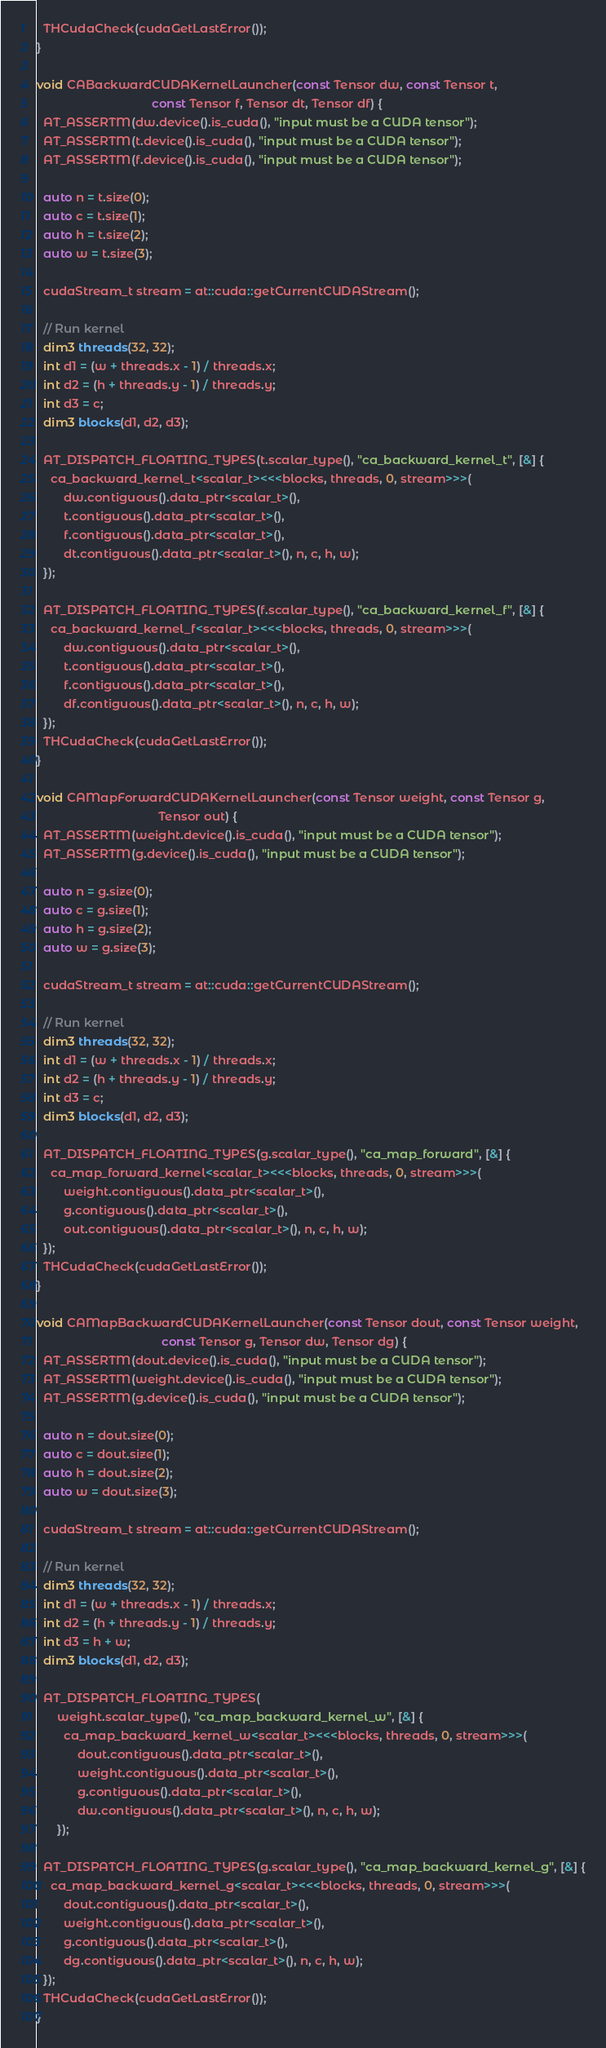Convert code to text. <code><loc_0><loc_0><loc_500><loc_500><_Cuda_>  THCudaCheck(cudaGetLastError());
}

void CABackwardCUDAKernelLauncher(const Tensor dw, const Tensor t,
                                  const Tensor f, Tensor dt, Tensor df) {
  AT_ASSERTM(dw.device().is_cuda(), "input must be a CUDA tensor");
  AT_ASSERTM(t.device().is_cuda(), "input must be a CUDA tensor");
  AT_ASSERTM(f.device().is_cuda(), "input must be a CUDA tensor");

  auto n = t.size(0);
  auto c = t.size(1);
  auto h = t.size(2);
  auto w = t.size(3);

  cudaStream_t stream = at::cuda::getCurrentCUDAStream();

  // Run kernel
  dim3 threads(32, 32);
  int d1 = (w + threads.x - 1) / threads.x;
  int d2 = (h + threads.y - 1) / threads.y;
  int d3 = c;
  dim3 blocks(d1, d2, d3);

  AT_DISPATCH_FLOATING_TYPES(t.scalar_type(), "ca_backward_kernel_t", [&] {
    ca_backward_kernel_t<scalar_t><<<blocks, threads, 0, stream>>>(
        dw.contiguous().data_ptr<scalar_t>(),
        t.contiguous().data_ptr<scalar_t>(),
        f.contiguous().data_ptr<scalar_t>(),
        dt.contiguous().data_ptr<scalar_t>(), n, c, h, w);
  });

  AT_DISPATCH_FLOATING_TYPES(f.scalar_type(), "ca_backward_kernel_f", [&] {
    ca_backward_kernel_f<scalar_t><<<blocks, threads, 0, stream>>>(
        dw.contiguous().data_ptr<scalar_t>(),
        t.contiguous().data_ptr<scalar_t>(),
        f.contiguous().data_ptr<scalar_t>(),
        df.contiguous().data_ptr<scalar_t>(), n, c, h, w);
  });
  THCudaCheck(cudaGetLastError());
}

void CAMapForwardCUDAKernelLauncher(const Tensor weight, const Tensor g,
                                    Tensor out) {
  AT_ASSERTM(weight.device().is_cuda(), "input must be a CUDA tensor");
  AT_ASSERTM(g.device().is_cuda(), "input must be a CUDA tensor");

  auto n = g.size(0);
  auto c = g.size(1);
  auto h = g.size(2);
  auto w = g.size(3);

  cudaStream_t stream = at::cuda::getCurrentCUDAStream();

  // Run kernel
  dim3 threads(32, 32);
  int d1 = (w + threads.x - 1) / threads.x;
  int d2 = (h + threads.y - 1) / threads.y;
  int d3 = c;
  dim3 blocks(d1, d2, d3);

  AT_DISPATCH_FLOATING_TYPES(g.scalar_type(), "ca_map_forward", [&] {
    ca_map_forward_kernel<scalar_t><<<blocks, threads, 0, stream>>>(
        weight.contiguous().data_ptr<scalar_t>(),
        g.contiguous().data_ptr<scalar_t>(),
        out.contiguous().data_ptr<scalar_t>(), n, c, h, w);
  });
  THCudaCheck(cudaGetLastError());
}

void CAMapBackwardCUDAKernelLauncher(const Tensor dout, const Tensor weight,
                                     const Tensor g, Tensor dw, Tensor dg) {
  AT_ASSERTM(dout.device().is_cuda(), "input must be a CUDA tensor");
  AT_ASSERTM(weight.device().is_cuda(), "input must be a CUDA tensor");
  AT_ASSERTM(g.device().is_cuda(), "input must be a CUDA tensor");

  auto n = dout.size(0);
  auto c = dout.size(1);
  auto h = dout.size(2);
  auto w = dout.size(3);

  cudaStream_t stream = at::cuda::getCurrentCUDAStream();

  // Run kernel
  dim3 threads(32, 32);
  int d1 = (w + threads.x - 1) / threads.x;
  int d2 = (h + threads.y - 1) / threads.y;
  int d3 = h + w;
  dim3 blocks(d1, d2, d3);

  AT_DISPATCH_FLOATING_TYPES(
      weight.scalar_type(), "ca_map_backward_kernel_w", [&] {
        ca_map_backward_kernel_w<scalar_t><<<blocks, threads, 0, stream>>>(
            dout.contiguous().data_ptr<scalar_t>(),
            weight.contiguous().data_ptr<scalar_t>(),
            g.contiguous().data_ptr<scalar_t>(),
            dw.contiguous().data_ptr<scalar_t>(), n, c, h, w);
      });

  AT_DISPATCH_FLOATING_TYPES(g.scalar_type(), "ca_map_backward_kernel_g", [&] {
    ca_map_backward_kernel_g<scalar_t><<<blocks, threads, 0, stream>>>(
        dout.contiguous().data_ptr<scalar_t>(),
        weight.contiguous().data_ptr<scalar_t>(),
        g.contiguous().data_ptr<scalar_t>(),
        dg.contiguous().data_ptr<scalar_t>(), n, c, h, w);
  });
  THCudaCheck(cudaGetLastError());
}
</code> 